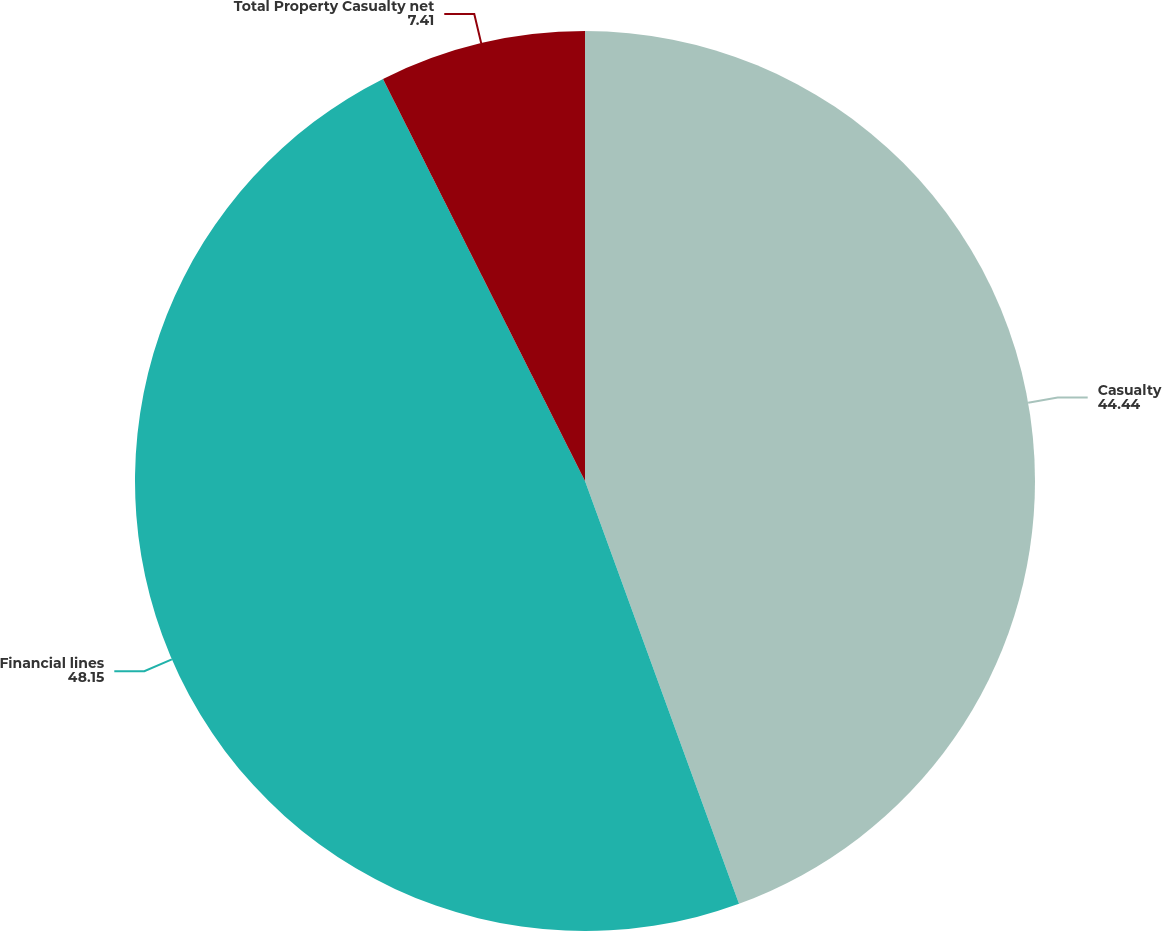Convert chart to OTSL. <chart><loc_0><loc_0><loc_500><loc_500><pie_chart><fcel>Casualty<fcel>Financial lines<fcel>Total Property Casualty net<nl><fcel>44.44%<fcel>48.15%<fcel>7.41%<nl></chart> 